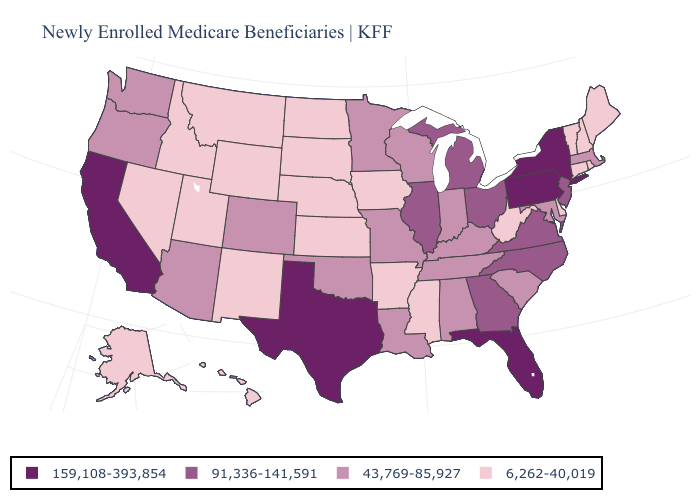What is the lowest value in states that border Ohio?
Give a very brief answer. 6,262-40,019. Name the states that have a value in the range 159,108-393,854?
Quick response, please. California, Florida, New York, Pennsylvania, Texas. Does Alaska have the lowest value in the USA?
Give a very brief answer. Yes. Does Kentucky have the lowest value in the South?
Short answer required. No. Among the states that border Kansas , does Nebraska have the lowest value?
Be succinct. Yes. What is the lowest value in the MidWest?
Keep it brief. 6,262-40,019. Does Michigan have the same value as Illinois?
Write a very short answer. Yes. Does Texas have the highest value in the USA?
Give a very brief answer. Yes. Name the states that have a value in the range 43,769-85,927?
Write a very short answer. Alabama, Arizona, Colorado, Indiana, Kentucky, Louisiana, Maryland, Massachusetts, Minnesota, Missouri, Oklahoma, Oregon, South Carolina, Tennessee, Washington, Wisconsin. Among the states that border Texas , which have the lowest value?
Answer briefly. Arkansas, New Mexico. Name the states that have a value in the range 43,769-85,927?
Keep it brief. Alabama, Arizona, Colorado, Indiana, Kentucky, Louisiana, Maryland, Massachusetts, Minnesota, Missouri, Oklahoma, Oregon, South Carolina, Tennessee, Washington, Wisconsin. What is the value of Wisconsin?
Be succinct. 43,769-85,927. What is the highest value in the USA?
Short answer required. 159,108-393,854. What is the lowest value in states that border Wyoming?
Answer briefly. 6,262-40,019. What is the lowest value in the MidWest?
Keep it brief. 6,262-40,019. 